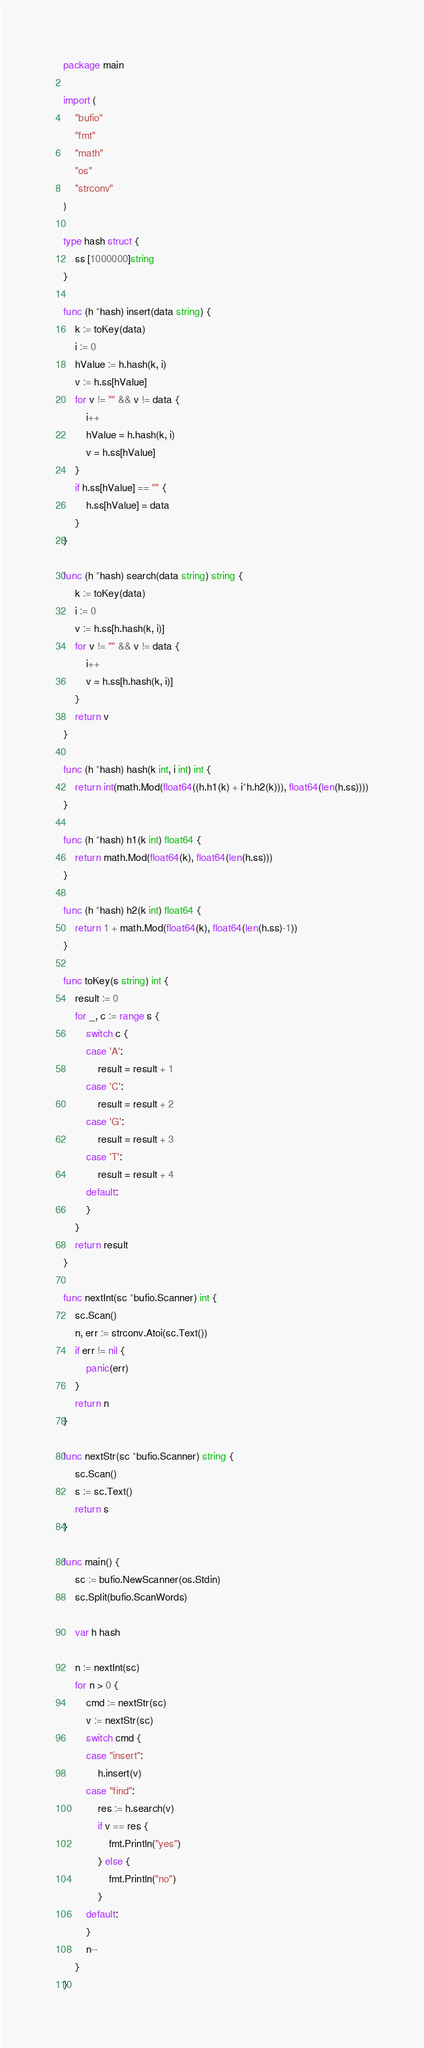<code> <loc_0><loc_0><loc_500><loc_500><_Go_>package main

import (
	"bufio"
	"fmt"
	"math"
	"os"
	"strconv"
)

type hash struct {
	ss [1000000]string
}

func (h *hash) insert(data string) {
	k := toKey(data)
	i := 0
	hValue := h.hash(k, i)
	v := h.ss[hValue]
	for v != "" && v != data {
		i++
		hValue = h.hash(k, i)
		v = h.ss[hValue]
	}
	if h.ss[hValue] == "" {
		h.ss[hValue] = data
	}
}

func (h *hash) search(data string) string {
	k := toKey(data)
	i := 0
	v := h.ss[h.hash(k, i)]
	for v != "" && v != data {
		i++
		v = h.ss[h.hash(k, i)]
	}
	return v
}

func (h *hash) hash(k int, i int) int {
	return int(math.Mod(float64((h.h1(k) + i*h.h2(k))), float64(len(h.ss))))
}

func (h *hash) h1(k int) float64 {
	return math.Mod(float64(k), float64(len(h.ss)))
}

func (h *hash) h2(k int) float64 {
	return 1 + math.Mod(float64(k), float64(len(h.ss)-1))
}

func toKey(s string) int {
	result := 0
	for _, c := range s {
		switch c {
		case 'A':
			result = result + 1
		case 'C':
			result = result + 2
		case 'G':
			result = result + 3
		case 'T':
			result = result + 4
		default:
		}
	}
	return result
}

func nextInt(sc *bufio.Scanner) int {
	sc.Scan()
	n, err := strconv.Atoi(sc.Text())
	if err != nil {
		panic(err)
	}
	return n
}

func nextStr(sc *bufio.Scanner) string {
	sc.Scan()
	s := sc.Text()
	return s
}

func main() {
	sc := bufio.NewScanner(os.Stdin)
	sc.Split(bufio.ScanWords)

	var h hash

	n := nextInt(sc)
	for n > 0 {
		cmd := nextStr(sc)
		v := nextStr(sc)
		switch cmd {
		case "insert":
			h.insert(v)
		case "find":
			res := h.search(v)
			if v == res {
				fmt.Println("yes")
			} else {
				fmt.Println("no")
			}
		default:
		}
		n--
	}
}

</code> 